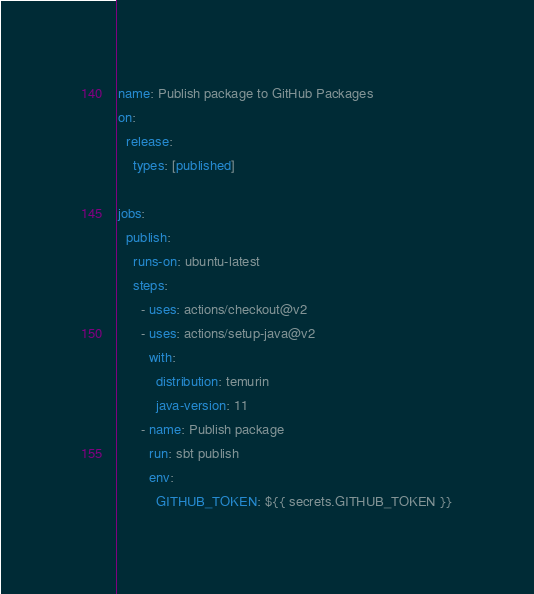<code> <loc_0><loc_0><loc_500><loc_500><_YAML_>name: Publish package to GitHub Packages
on:
  release:
    types: [published]

jobs:
  publish:
    runs-on: ubuntu-latest
    steps:
      - uses: actions/checkout@v2
      - uses: actions/setup-java@v2
        with:
          distribution: temurin
          java-version: 11
      - name: Publish package
        run: sbt publish
        env:
          GITHUB_TOKEN: ${{ secrets.GITHUB_TOKEN }}</code> 